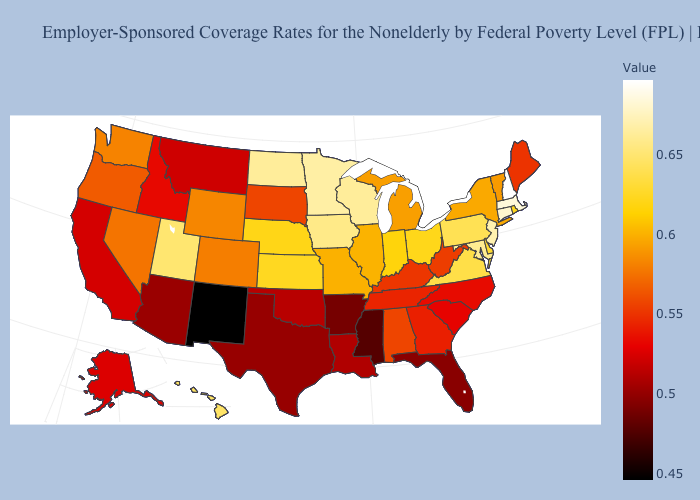Which states hav the highest value in the MidWest?
Concise answer only. Minnesota. Does Utah have a lower value than New Hampshire?
Concise answer only. Yes. 